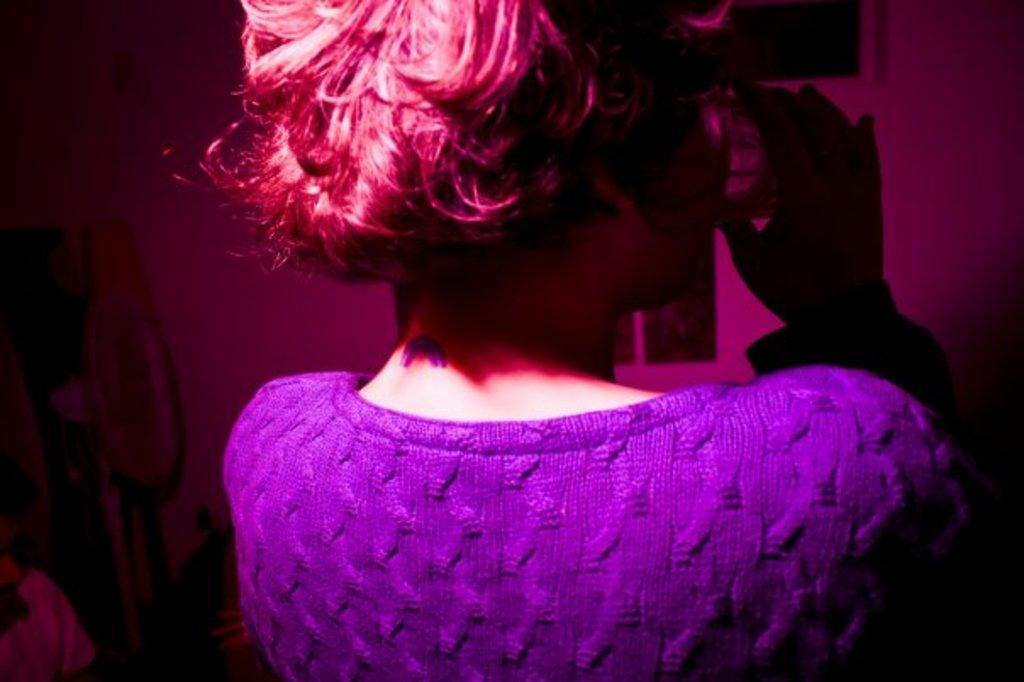Who is the main subject in the image? There is a lady in the image. What is the lady holding in the image? The lady is holding a glass. What can be seen in the background of the image? There is a wall in the background of the image. What type of line can be seen in the image? There is no line present in the image. Where is the market located in the image? There is no market present in the image. 